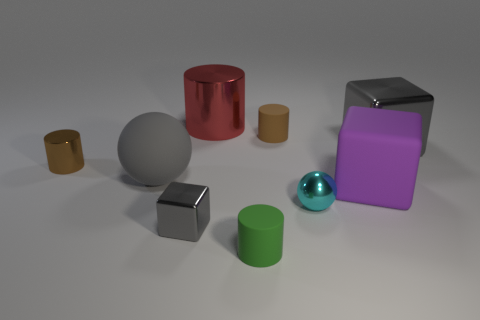Does the large metal thing that is on the right side of the purple object have the same color as the large rubber sphere?
Keep it short and to the point. Yes. Do the green matte cylinder and the brown metal cylinder have the same size?
Provide a succinct answer. Yes. The large object that is the same shape as the tiny brown shiny thing is what color?
Provide a short and direct response. Red. How many small metallic things have the same color as the rubber sphere?
Ensure brevity in your answer.  1. Is the number of spheres behind the purple rubber block greater than the number of small yellow cylinders?
Provide a short and direct response. Yes. What color is the metal block to the left of the gray object behind the brown metallic thing?
Ensure brevity in your answer.  Gray. What number of objects are either red objects that are behind the small brown shiny object or things that are on the left side of the small cyan metallic object?
Provide a short and direct response. 6. What color is the rubber block?
Give a very brief answer. Purple. What number of other small green things are the same material as the small green thing?
Offer a terse response. 0. Are there more tiny green cylinders than rubber cylinders?
Provide a short and direct response. No. 